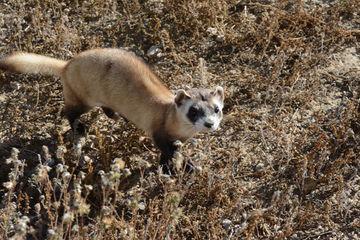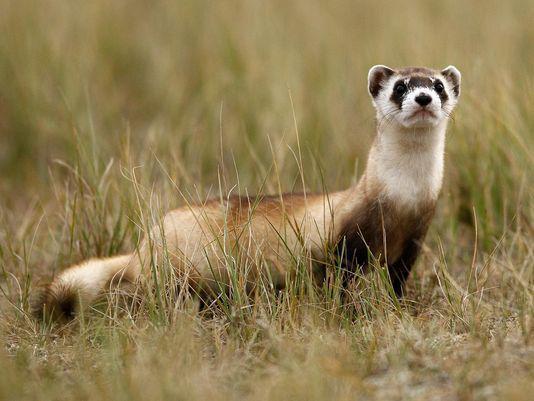The first image is the image on the left, the second image is the image on the right. Considering the images on both sides, is "Each image contains the same number of animals." valid? Answer yes or no. Yes. 